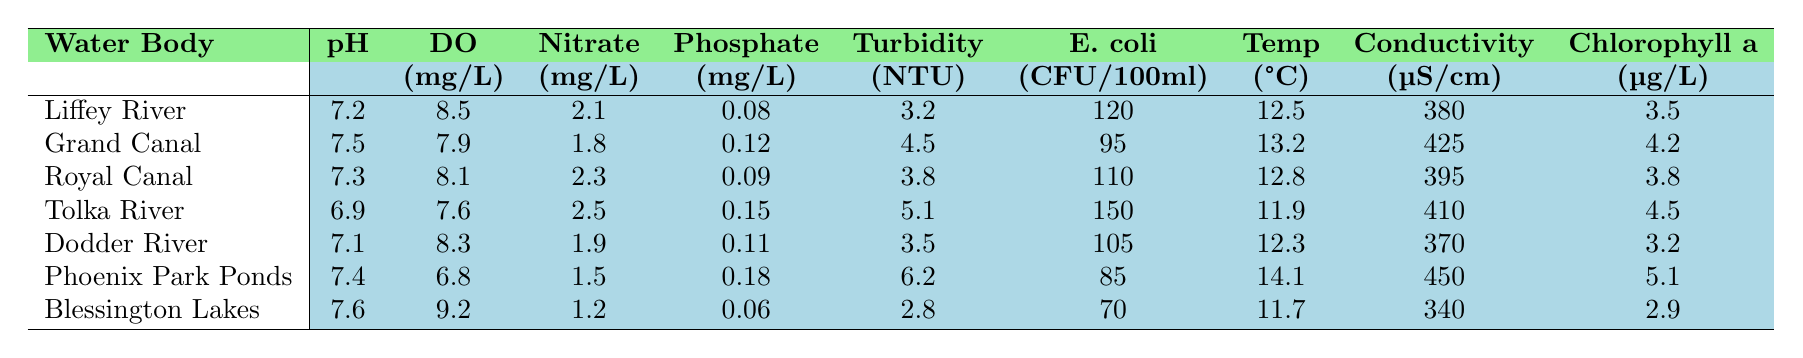What is the pH level of the Dodder River? The pH level for the Dodder River is listed directly in the table under the pH column, which shows a value of 7.1.
Answer: 7.1 Which water body has the highest concentration of dissolved oxygen? By comparing the dissolved oxygen values for each water body, the Phoenix Park Ponds has the lowest value at 6.8 mg/L, while the Blessington Lakes has the highest at 9.2 mg/L.
Answer: Blessington Lakes What is the average nitrate level across all water bodies? To find the average, add up all the nitrate levels: (2.1 + 1.8 + 2.3 + 2.5 + 1.9 + 1.5 + 1.2) = 13.3. There are 7 values, so divide by 7: 13.3/7 = 1.9.
Answer: 1.9 Is the phosphate level in the Royal Canal higher than in the Dodder River? Comparing the phosphate values reveals that the Royal Canal has 0.09 mg/L and the Dodder River has 0.11 mg/L, so the statement is incorrect.
Answer: No Which water body has the lowest turbidity and what is that value? The turbidity is lowest in the Blessington Lakes, with a value of 2.8 NTU as shown in the turbidity column of the table.
Answer: Blessington Lakes, 2.8 NTU Calculate the total E. coli count for all water bodies combined. To calculate the total, we add all the E. coli values: (120 + 95 + 110 + 150 + 105 + 85 + 70) = 735.
Answer: 735 What is the water temperature of the Grand Canal? The water temperature is shown in the table under the temperature column for the Grand Canal, which indicates a temperature of 13.2 °C.
Answer: 13.2 °C Is the conductivity of the Liffey River less than that of the Phoenix Park Ponds? Checking the values, the Liffey River has a conductivity of 380 µS/cm while the Phoenix Park Ponds has 450 µS/cm, confirming the statement is true.
Answer: Yes Which water body has the highest chloride a concentration, and what is the value? The table indicates that the highest chlorophyll a concentration is found in the Phoenix Park Ponds at 5.1 µg/L, which is the highest value in the chlorophyll a column.
Answer: Phoenix Park Ponds, 5.1 µg/L What is the difference in dissolved oxygen between the Liffey River and the Tolka River? The dissolved oxygen level in the Liffey River is 8.5 mg/L, while the Tolka River is 7.6 mg/L. The difference is calculated as 8.5 - 7.6 = 0.9 mg/L.
Answer: 0.9 mg/L 